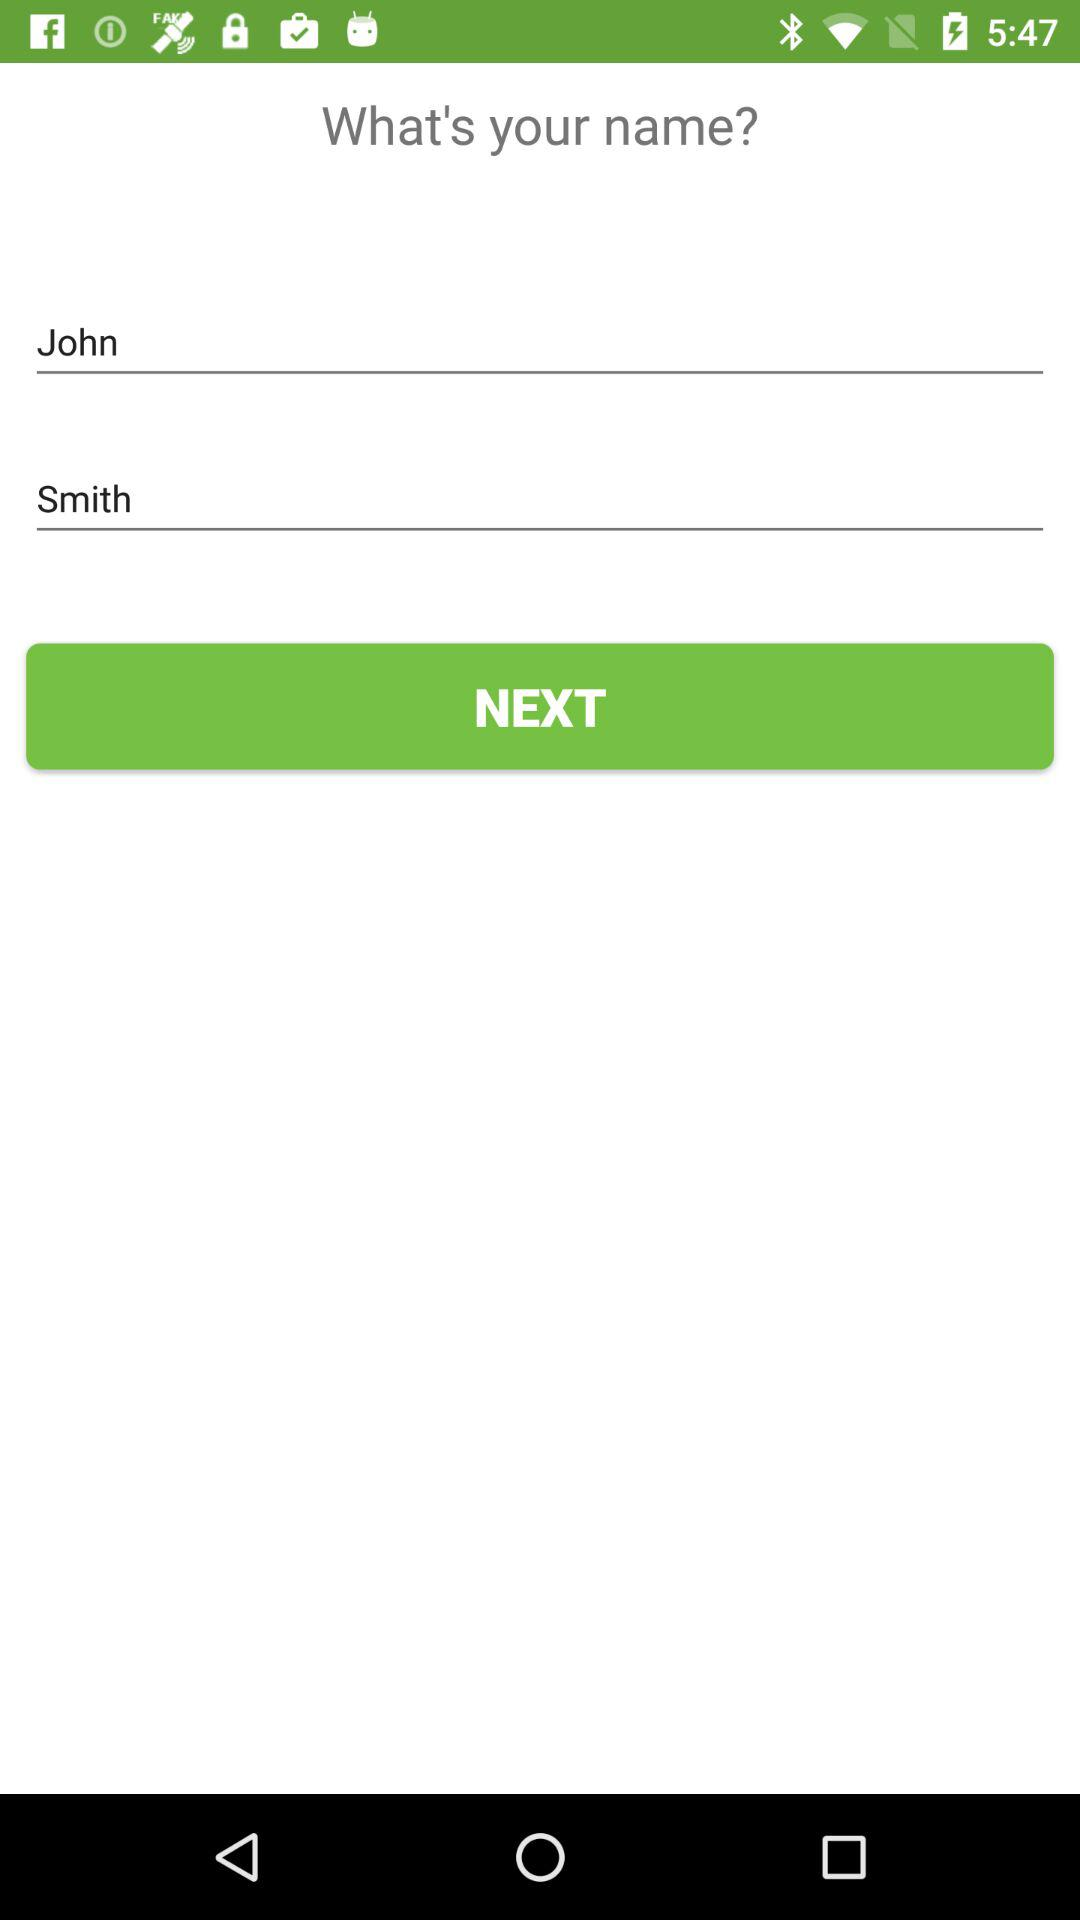What is the user name? The user name is John Smith. 